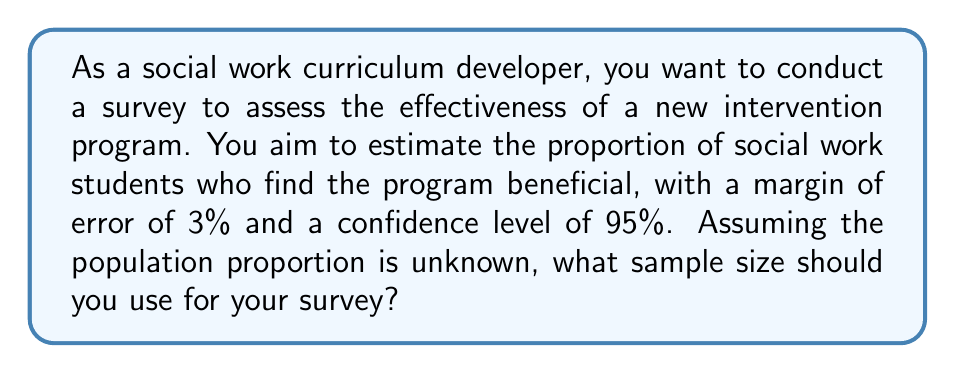What is the answer to this math problem? To determine the required sample size, we'll use the formula for sample size calculation when estimating a population proportion:

$$n = \frac{z^2 \cdot p(1-p)}{E^2}$$

Where:
$n$ = required sample size
$z$ = z-score corresponding to the desired confidence level
$p$ = estimated population proportion
$E$ = desired margin of error

Step 1: Determine the z-score for a 95% confidence level.
For 95% confidence, $z = 1.96$

Step 2: Set the estimated population proportion.
Since the true population proportion is unknown, we use $p = 0.5$ to get the most conservative (largest) sample size.

Step 3: Convert the margin of error to a decimal.
$E = 3\% = 0.03$

Step 4: Plug the values into the formula:

$$n = \frac{1.96^2 \cdot 0.5(1-0.5)}{0.03^2}$$

Step 5: Calculate the result:

$$n = \frac{3.8416 \cdot 0.25}{0.0009} = 1067.11$$

Step 6: Round up to the nearest whole number:

$n = 1068$

Therefore, you should survey at least 1,068 social work students to achieve the desired margin of error and confidence level.
Answer: 1,068 students 